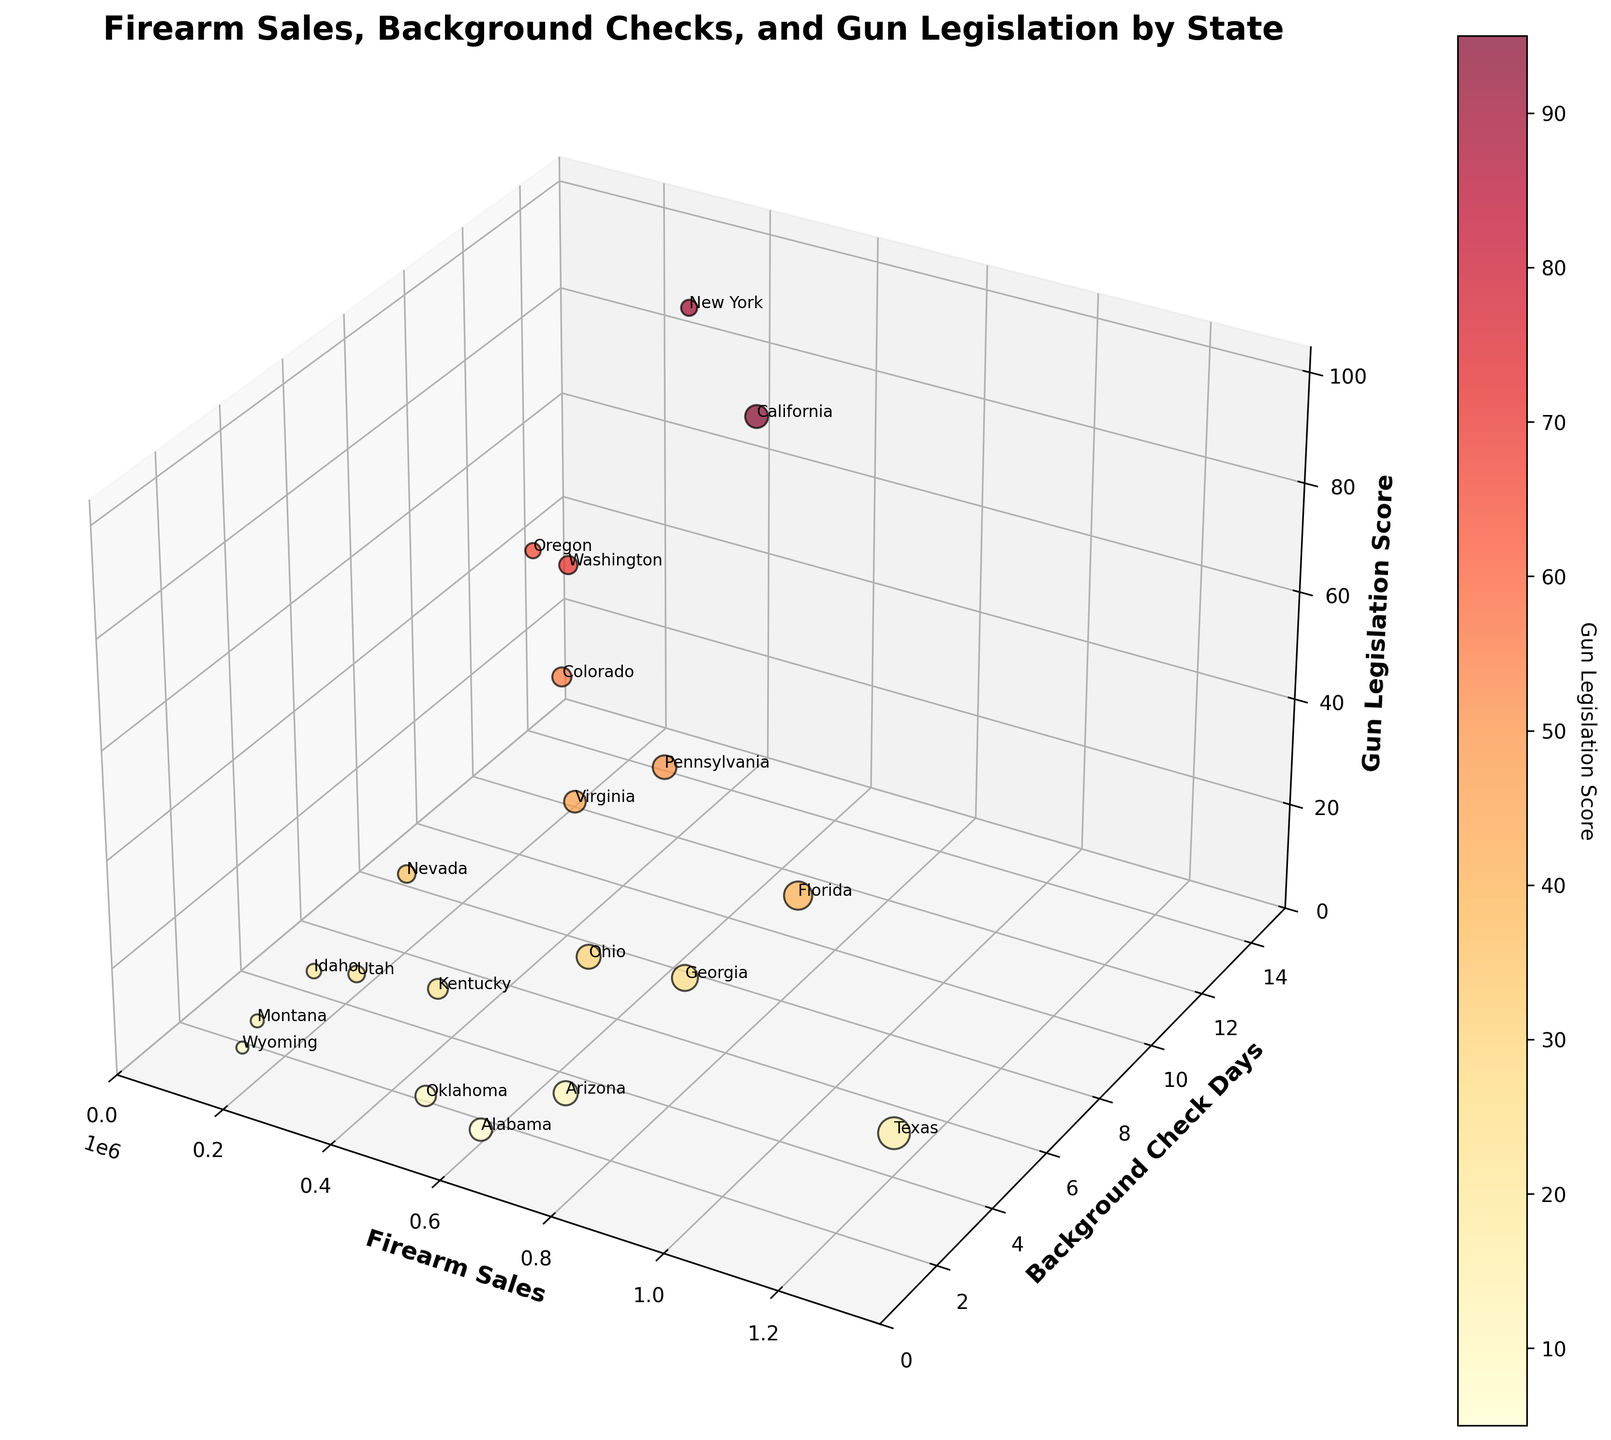What's the title of the figure? The title is displayed at the top of the figure in large, bold font.
Answer: "Firearm Sales, Background Checks, and Gun Legislation by State" How many days do background checks take in California? Look at the y-axis and find California's data point. The y-axis value here corresponds to the number of days it takes for background checks.
Answer: 10 Which state has the highest Firearm Sales? Identify the data point that is farthest along the x-axis, which corresponds to Firearm Sales. The state label for this point will tell you which state it is.
Answer: Texas What's the data range for the Gun Legislation Score? Examine the z-axis, noting the lowest and highest values along it. The range is the difference between these two values.
Answer: 5 to 95 Which state has the shortest background check time? Find the data points along the y-axis that have a value of 1, then look at the state labels for these points.
Answer: Alabama, Oklahoma, Montana, Wyoming What is the approximate ratio of Firearm Sales between Texas and New York? Look for both Texas and New York data points along the x-axis representing Firearm Sales. Compute the ratio by dividing Texas's Firearm Sales number by New York's.
Answer: Approximately 4:1 Do states with longer background check times generally have higher Gun Legislation Scores? Examine the trend along the y-axis (Background Check Days) and z-axis (Gun Legislation Score). Look to see if higher y-values correspond to higher z-values.
Answer: Yes Which state has the highest Gun Legislation Score? Look at the data point furthest on the z-axis, indicating the highest Gun Legislation Score, then find which state label it belongs to.
Answer: California Compare the Firearm Sales of Arizona and Colorado. Which state has more? Identify the x-axis values for both Arizona and Colorado, then compare the values.
Answer: Arizona What's the sum of days for background checks in Texas, Florida, and New York? Add the y-axis values for Texas (3), Florida (5), and New York (14). This involves simple addition to find the total.
Answer: 22 